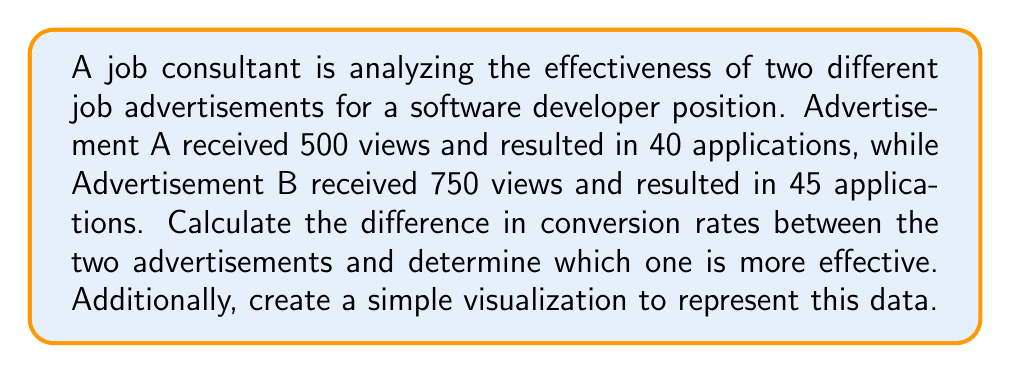Could you help me with this problem? To solve this problem, we need to follow these steps:

1. Calculate the conversion rate for each advertisement:
   Conversion rate = (Number of applications / Number of views) * 100

   For Advertisement A:
   $$\text{Conversion Rate A} = \frac{40}{500} \times 100 = 8\%$$

   For Advertisement B:
   $$\text{Conversion Rate B} = \frac{45}{750} \times 100 = 6\%$$

2. Calculate the difference in conversion rates:
   $$\text{Difference} = \text{Conversion Rate A} - \text{Conversion Rate B} = 8\% - 6\% = 2\%$$

3. Determine which advertisement is more effective:
   Advertisement A has a higher conversion rate (8% vs 6%), so it is more effective.

4. Create a simple visualization to represent the data:

[asy]
import graph;
size(200,150);

real[] views = {500, 750};
real[] applications = {40, 45};

// Bar chart for views
for(int i=0; i<2; ++i) {
  fill(shift((i*3,0))*scale(1,views[i]/100)*unitsquare, rgb(0.6,0.6,1));
  label("Ad "+(string)(i+1), (i*3+0.5,0), S);
  label(string(views[i]), (i*3+0.5,views[i]/100), N);
}

// Bar chart for applications
for(int i=0; i<2; ++i) {
  fill(shift((i*3+1.5,0))*scale(1,applications[i]/5)*unitsquare, rgb(1,0.6,0.6));
  label(string(applications[i]), (i*3+1.5,applications[i]/5), N);
}

label("Views", (-1,5), W, rgb(0.6,0.6,1));
label("Applications", (-1,4), W, rgb(1,0.6,0.6));
[/asy]

This visualization shows the number of views (blue) and applications (red) for each advertisement, allowing for easy comparison of their performance.
Answer: Advertisement A is more effective with a 2% higher conversion rate. 